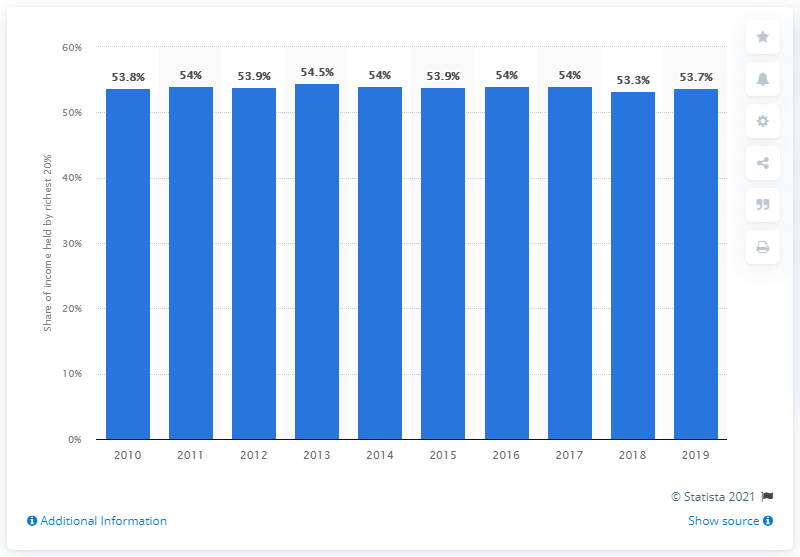List a handful of essential elements in this visual. According to a report, in 2019, the richest 20 percent of Costa Rica's population held 53.7 percent of the country's total income. This suggests that a significant portion of the country's wealth is concentrated among a small percentage of the population. 